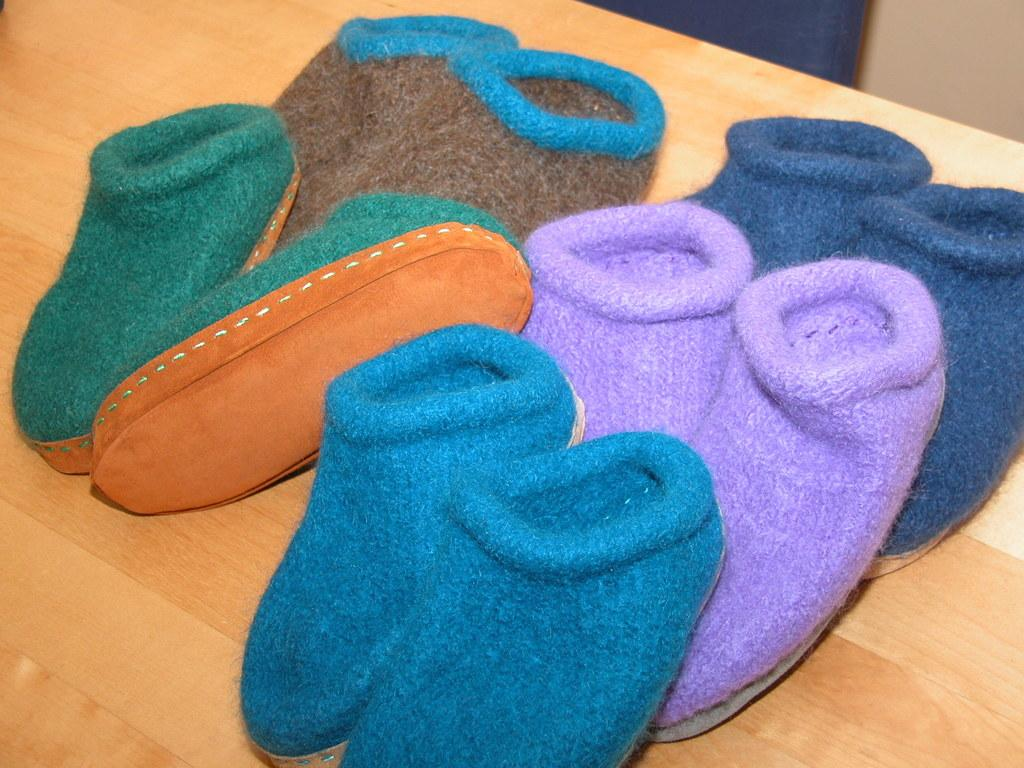What type of shoes are in the image? There are woolen shoes in the image. Where are the woolen shoes located? The woolen shoes are on a table. What type of plant is growing out of the woolen shoes in the image? There is no plant growing out of the woolen shoes in the image. What day of the week is depicted in the image? The day of the week is not depicted in the image, as it only shows woolen shoes on a table. 